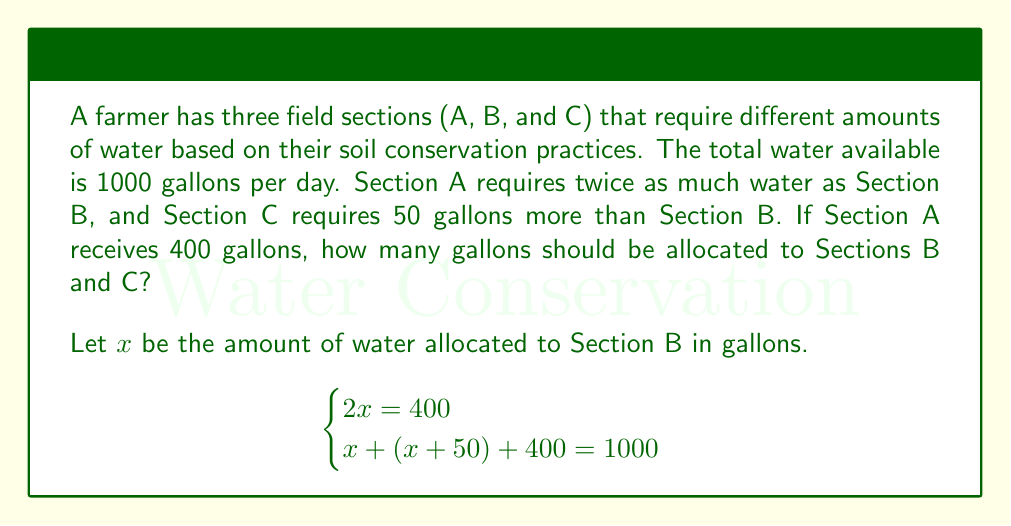Help me with this question. To solve this system of equations, we'll follow these steps:

1. From the first equation, we can determine the value of $x$:
   $2x = 400$
   $x = 200$

2. Now that we know $x = 200$, we can calculate the water allocation for Section C:
   Section C = $x + 50 = 200 + 50 = 250$ gallons

3. Let's verify our solution using the second equation:
   $x + (x + 50) + 400 = 1000$
   $200 + 250 + 400 = 850$

4. The total water allocated is 850 gallons, which is less than the available 1000 gallons. This means our solution is valid, and there is a surplus of 150 gallons.

Therefore, Section B should receive 200 gallons, and Section C should receive 250 gallons of water.
Answer: Section B: 200 gallons
Section C: 250 gallons 